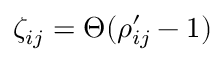Convert formula to latex. <formula><loc_0><loc_0><loc_500><loc_500>\zeta _ { i j } = \Theta ( \rho _ { i j } ^ { \prime } - 1 )</formula> 